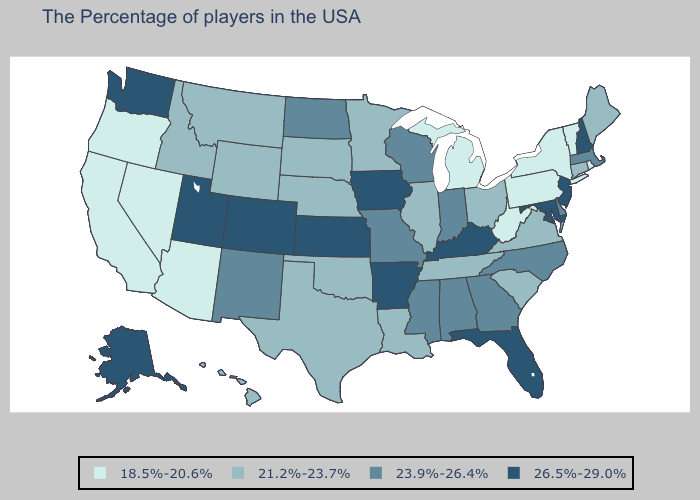Name the states that have a value in the range 26.5%-29.0%?
Be succinct. New Hampshire, New Jersey, Maryland, Florida, Kentucky, Arkansas, Iowa, Kansas, Colorado, Utah, Washington, Alaska. What is the lowest value in the Northeast?
Short answer required. 18.5%-20.6%. Does the first symbol in the legend represent the smallest category?
Keep it brief. Yes. Which states have the highest value in the USA?
Concise answer only. New Hampshire, New Jersey, Maryland, Florida, Kentucky, Arkansas, Iowa, Kansas, Colorado, Utah, Washington, Alaska. Name the states that have a value in the range 23.9%-26.4%?
Keep it brief. Massachusetts, Delaware, North Carolina, Georgia, Indiana, Alabama, Wisconsin, Mississippi, Missouri, North Dakota, New Mexico. What is the value of Utah?
Quick response, please. 26.5%-29.0%. Which states have the lowest value in the USA?
Be succinct. Rhode Island, Vermont, New York, Pennsylvania, West Virginia, Michigan, Arizona, Nevada, California, Oregon. Does North Dakota have a higher value than New Hampshire?
Answer briefly. No. Among the states that border New York , which have the highest value?
Quick response, please. New Jersey. What is the lowest value in states that border New Mexico?
Give a very brief answer. 18.5%-20.6%. Does the map have missing data?
Write a very short answer. No. What is the value of Idaho?
Quick response, please. 21.2%-23.7%. How many symbols are there in the legend?
Short answer required. 4. Does the map have missing data?
Keep it brief. No. Name the states that have a value in the range 21.2%-23.7%?
Be succinct. Maine, Connecticut, Virginia, South Carolina, Ohio, Tennessee, Illinois, Louisiana, Minnesota, Nebraska, Oklahoma, Texas, South Dakota, Wyoming, Montana, Idaho, Hawaii. 